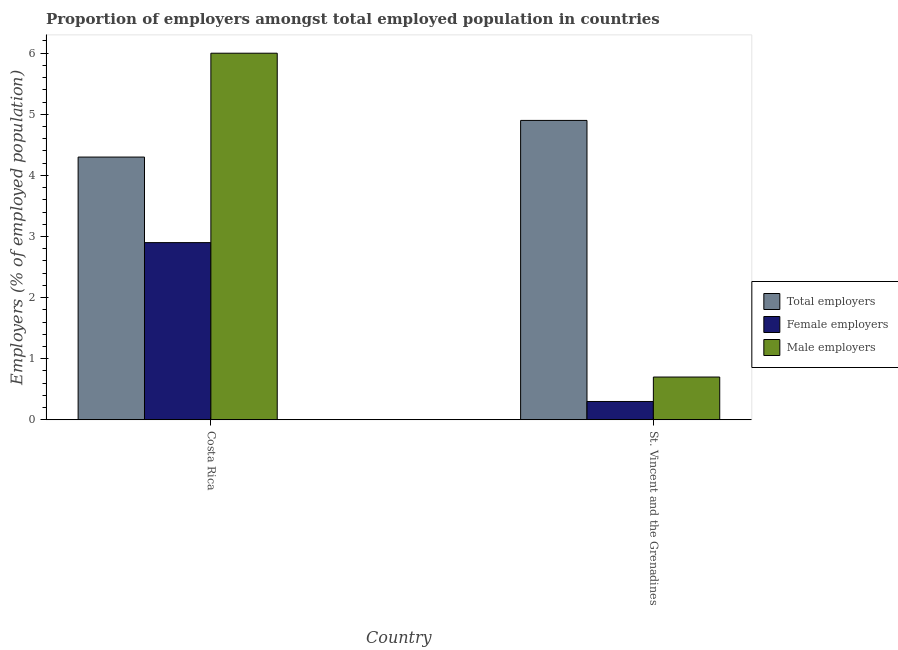How many groups of bars are there?
Your response must be concise. 2. How many bars are there on the 1st tick from the left?
Give a very brief answer. 3. What is the label of the 2nd group of bars from the left?
Your answer should be very brief. St. Vincent and the Grenadines. What is the percentage of male employers in St. Vincent and the Grenadines?
Offer a very short reply. 0.7. Across all countries, what is the maximum percentage of male employers?
Offer a very short reply. 6. Across all countries, what is the minimum percentage of female employers?
Ensure brevity in your answer.  0.3. In which country was the percentage of male employers maximum?
Provide a succinct answer. Costa Rica. In which country was the percentage of male employers minimum?
Provide a succinct answer. St. Vincent and the Grenadines. What is the total percentage of female employers in the graph?
Your answer should be very brief. 3.2. What is the difference between the percentage of total employers in Costa Rica and that in St. Vincent and the Grenadines?
Provide a succinct answer. -0.6. What is the difference between the percentage of female employers in St. Vincent and the Grenadines and the percentage of male employers in Costa Rica?
Offer a terse response. -5.7. What is the average percentage of female employers per country?
Provide a short and direct response. 1.6. What is the difference between the percentage of male employers and percentage of total employers in Costa Rica?
Offer a very short reply. 1.7. What is the ratio of the percentage of female employers in Costa Rica to that in St. Vincent and the Grenadines?
Your answer should be very brief. 9.67. Is the percentage of male employers in Costa Rica less than that in St. Vincent and the Grenadines?
Give a very brief answer. No. In how many countries, is the percentage of total employers greater than the average percentage of total employers taken over all countries?
Offer a very short reply. 1. What does the 3rd bar from the left in Costa Rica represents?
Your answer should be very brief. Male employers. What does the 3rd bar from the right in Costa Rica represents?
Your answer should be very brief. Total employers. Is it the case that in every country, the sum of the percentage of total employers and percentage of female employers is greater than the percentage of male employers?
Offer a very short reply. Yes. How many countries are there in the graph?
Give a very brief answer. 2. What is the difference between two consecutive major ticks on the Y-axis?
Offer a terse response. 1. Does the graph contain any zero values?
Your answer should be very brief. No. Does the graph contain grids?
Your answer should be very brief. No. How many legend labels are there?
Give a very brief answer. 3. What is the title of the graph?
Make the answer very short. Proportion of employers amongst total employed population in countries. What is the label or title of the Y-axis?
Your response must be concise. Employers (% of employed population). What is the Employers (% of employed population) in Total employers in Costa Rica?
Your response must be concise. 4.3. What is the Employers (% of employed population) of Female employers in Costa Rica?
Your answer should be very brief. 2.9. What is the Employers (% of employed population) in Total employers in St. Vincent and the Grenadines?
Give a very brief answer. 4.9. What is the Employers (% of employed population) of Female employers in St. Vincent and the Grenadines?
Provide a succinct answer. 0.3. What is the Employers (% of employed population) of Male employers in St. Vincent and the Grenadines?
Make the answer very short. 0.7. Across all countries, what is the maximum Employers (% of employed population) of Total employers?
Your answer should be compact. 4.9. Across all countries, what is the maximum Employers (% of employed population) of Female employers?
Keep it short and to the point. 2.9. Across all countries, what is the minimum Employers (% of employed population) in Total employers?
Provide a succinct answer. 4.3. Across all countries, what is the minimum Employers (% of employed population) of Female employers?
Give a very brief answer. 0.3. Across all countries, what is the minimum Employers (% of employed population) in Male employers?
Ensure brevity in your answer.  0.7. What is the total Employers (% of employed population) of Male employers in the graph?
Provide a succinct answer. 6.7. What is the difference between the Employers (% of employed population) of Male employers in Costa Rica and that in St. Vincent and the Grenadines?
Make the answer very short. 5.3. What is the difference between the Employers (% of employed population) of Total employers in Costa Rica and the Employers (% of employed population) of Female employers in St. Vincent and the Grenadines?
Give a very brief answer. 4. What is the difference between the Employers (% of employed population) in Total employers in Costa Rica and the Employers (% of employed population) in Male employers in St. Vincent and the Grenadines?
Make the answer very short. 3.6. What is the difference between the Employers (% of employed population) in Female employers in Costa Rica and the Employers (% of employed population) in Male employers in St. Vincent and the Grenadines?
Your response must be concise. 2.2. What is the average Employers (% of employed population) in Total employers per country?
Provide a short and direct response. 4.6. What is the average Employers (% of employed population) in Female employers per country?
Offer a terse response. 1.6. What is the average Employers (% of employed population) in Male employers per country?
Your answer should be very brief. 3.35. What is the difference between the Employers (% of employed population) in Total employers and Employers (% of employed population) in Female employers in Costa Rica?
Provide a succinct answer. 1.4. What is the difference between the Employers (% of employed population) in Total employers and Employers (% of employed population) in Male employers in Costa Rica?
Make the answer very short. -1.7. What is the difference between the Employers (% of employed population) in Female employers and Employers (% of employed population) in Male employers in Costa Rica?
Keep it short and to the point. -3.1. What is the difference between the Employers (% of employed population) of Total employers and Employers (% of employed population) of Female employers in St. Vincent and the Grenadines?
Offer a terse response. 4.6. What is the ratio of the Employers (% of employed population) in Total employers in Costa Rica to that in St. Vincent and the Grenadines?
Offer a terse response. 0.88. What is the ratio of the Employers (% of employed population) in Female employers in Costa Rica to that in St. Vincent and the Grenadines?
Make the answer very short. 9.67. What is the ratio of the Employers (% of employed population) of Male employers in Costa Rica to that in St. Vincent and the Grenadines?
Your answer should be very brief. 8.57. What is the difference between the highest and the second highest Employers (% of employed population) in Total employers?
Ensure brevity in your answer.  0.6. What is the difference between the highest and the second highest Employers (% of employed population) in Female employers?
Your answer should be compact. 2.6. What is the difference between the highest and the second highest Employers (% of employed population) of Male employers?
Ensure brevity in your answer.  5.3. What is the difference between the highest and the lowest Employers (% of employed population) of Total employers?
Offer a terse response. 0.6. 